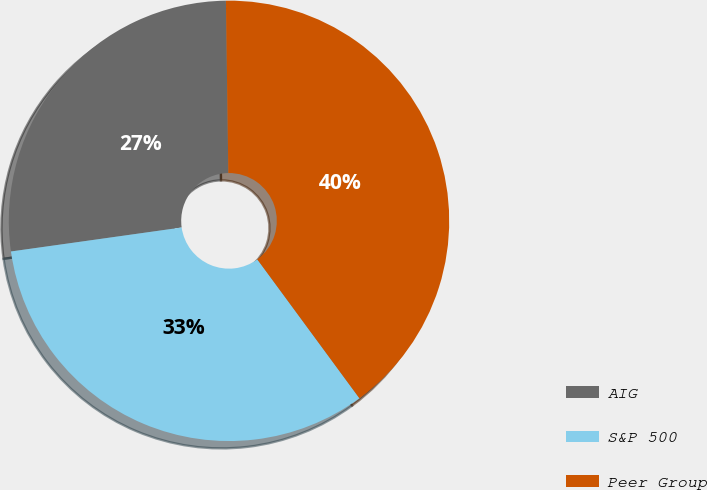<chart> <loc_0><loc_0><loc_500><loc_500><pie_chart><fcel>AIG<fcel>S&P 500<fcel>Peer Group<nl><fcel>27.0%<fcel>32.87%<fcel>40.13%<nl></chart> 